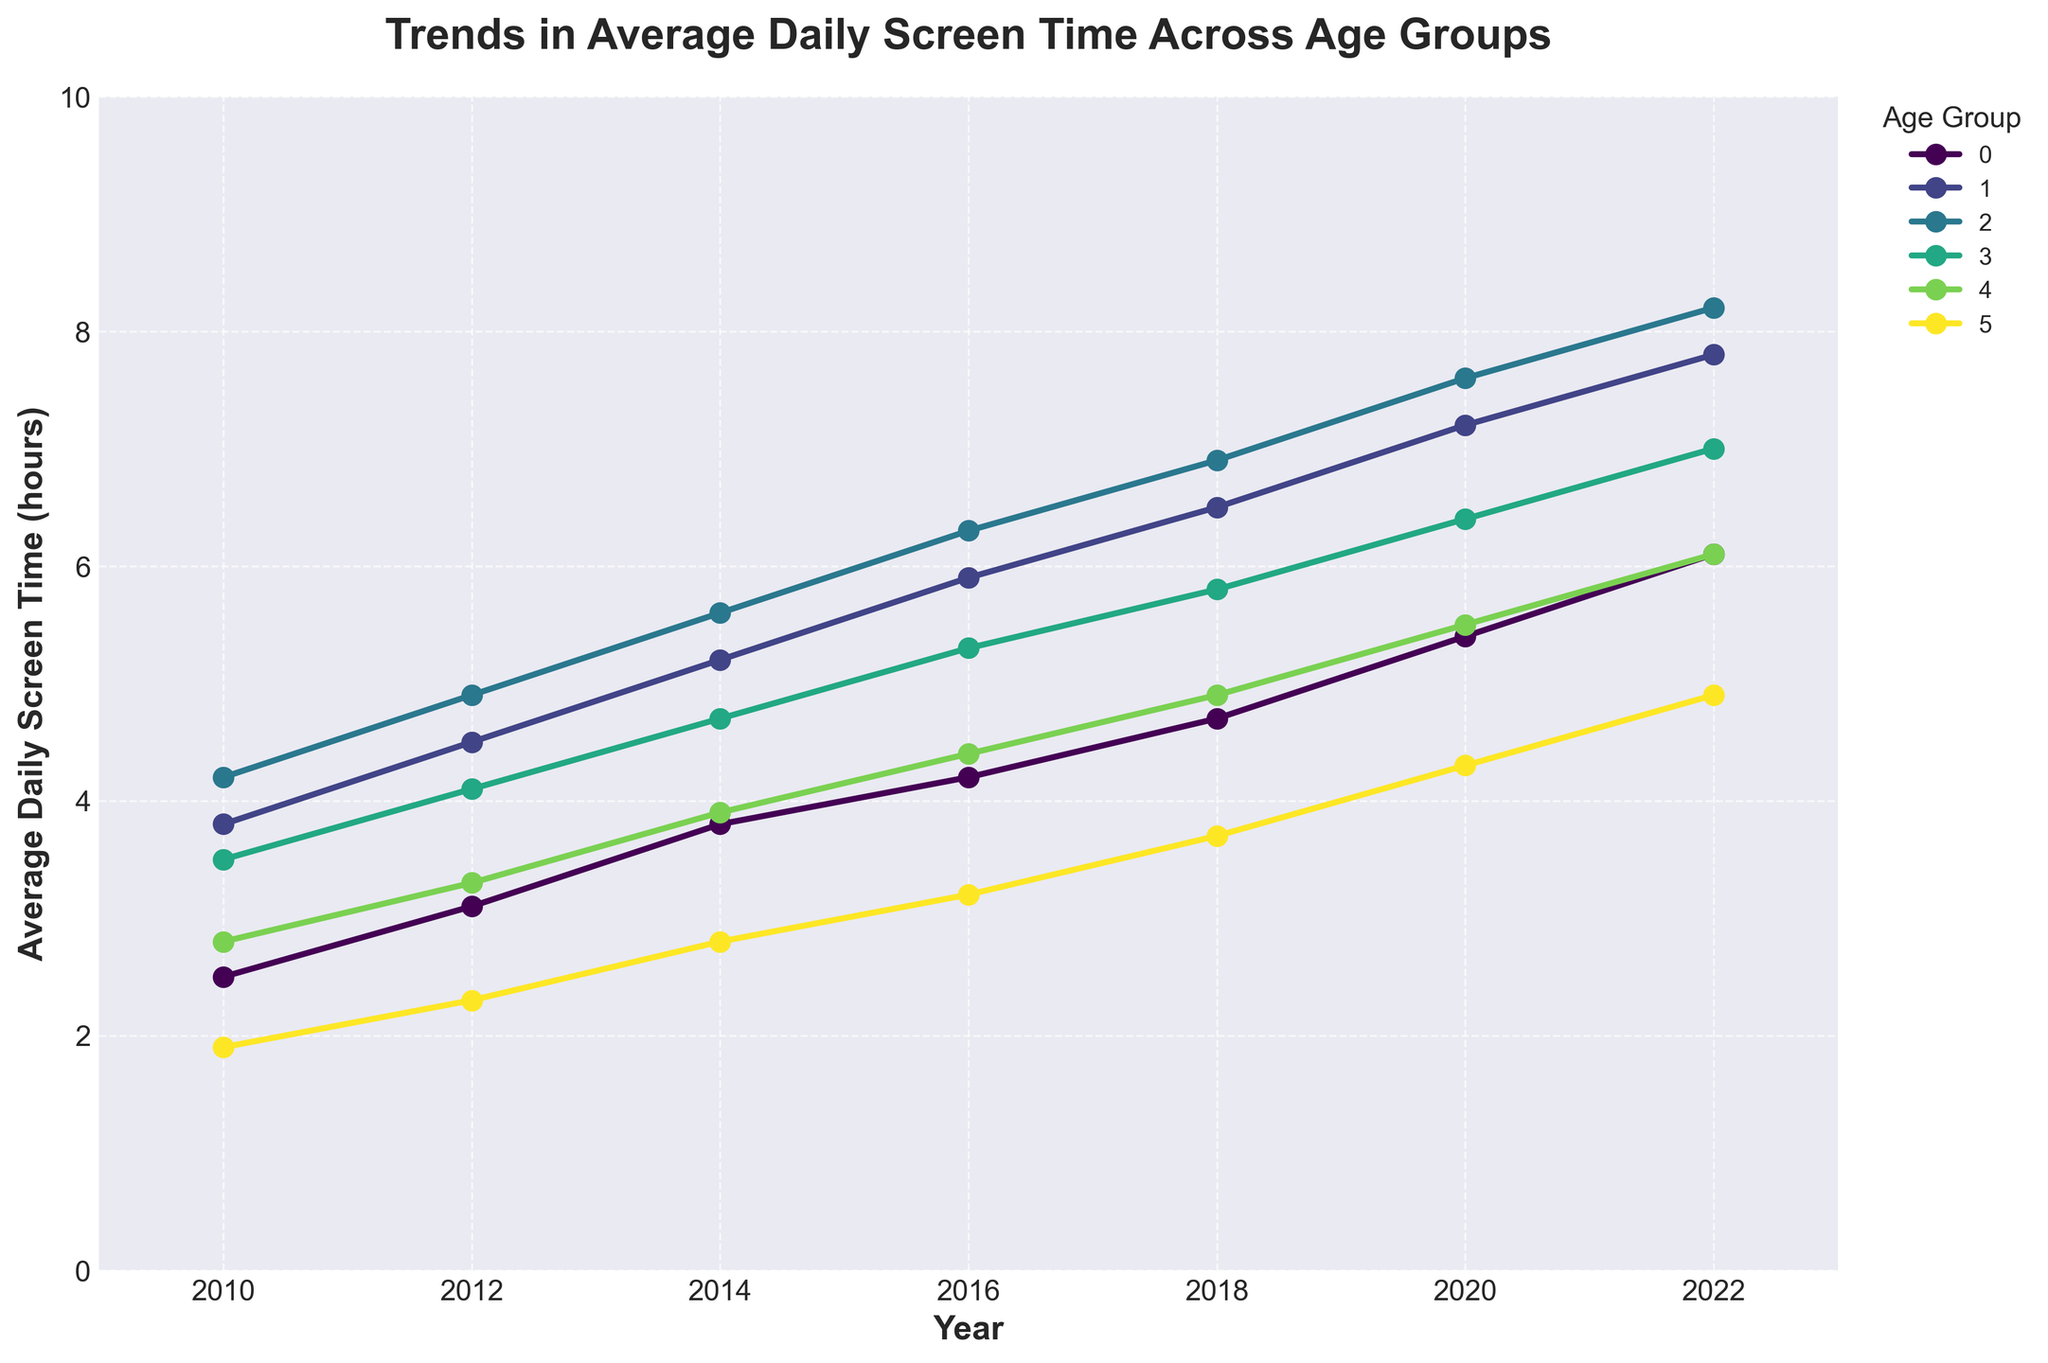What is the overall trend in average daily screen time for all age groups from 2010 to 2022? By observing all lines on the chart, it's evident that all age groups show an upward trend, indicating increasing daily screen time over the years.
Answer: Increasing Which age group had the highest average daily screen time in 2022? Locate the data points for 2022 and compare the values. The "Young Adults (20-29)" group had the highest value.
Answer: Young Adults (20-29) Which two age groups saw the same average daily screen time in 2022? Compare the data points for all age groups in 2022. Both "Children (5-12)" and "Middle-aged (50-64)" groups show a value of 6.1 hours.
Answer: Children (5-12) and Middle-aged (50-64) How much did the average daily screen time for "Teenagers (13-19)" increase from 2010 to 2022? Subtract the 2010 value for "Teenagers (13-19)" (3.8) from the 2022 value (7.8). The increase is 7.8 - 3.8 = 4 hours.
Answer: 4 hours By how many hours did the screen time for "Adults (30-49)" increase from 2010 to 2018? Subtract the 2010 value for "Adults (30-49)" (3.5) from the 2018 value (5.8). The increase is 5.8 - 3.5 = 2.3 hours.
Answer: 2.3 hours Which age group had the least increase in average daily screen time from 2010 to 2022? Calculate the increase for each age group by subtracting the 2010 value from the 2022 value. The "Seniors (65+)" group had the smallest increase of 4.9 - 1.9 = 3 hours.
Answer: Seniors (65+) In 2016, which two age groups had the closest average daily screen time, and what was the difference between them? Compare the 2016 values. "Children (5-12)" (4.2) and "Middle-aged (50-64)" (4.4) had the closest values, differing by 4.4 - 4.2 = 0.2 hours.
Answer: Children (5-12) and Middle-aged (50-64), 0.2 hours Which age group showed the most consistent increase in screen time from 2010 to 2022, based on the shape of the line in the chart? Look for the straightest/least variable line. "Young Adults (20-29)" has a consistent and steady increase throughout the years.
Answer: Young Adults (20-29) Comparing the trends, which age group had a more rapid increase in screen time after 2016, "Children (5-12)" or "Middle-aged (50-64)"? Inspect the slope of the lines for both age groups after 2016. The slope for "Children (5-12)" is steeper, indicating a more rapid increase.
Answer: Children (5-12) 